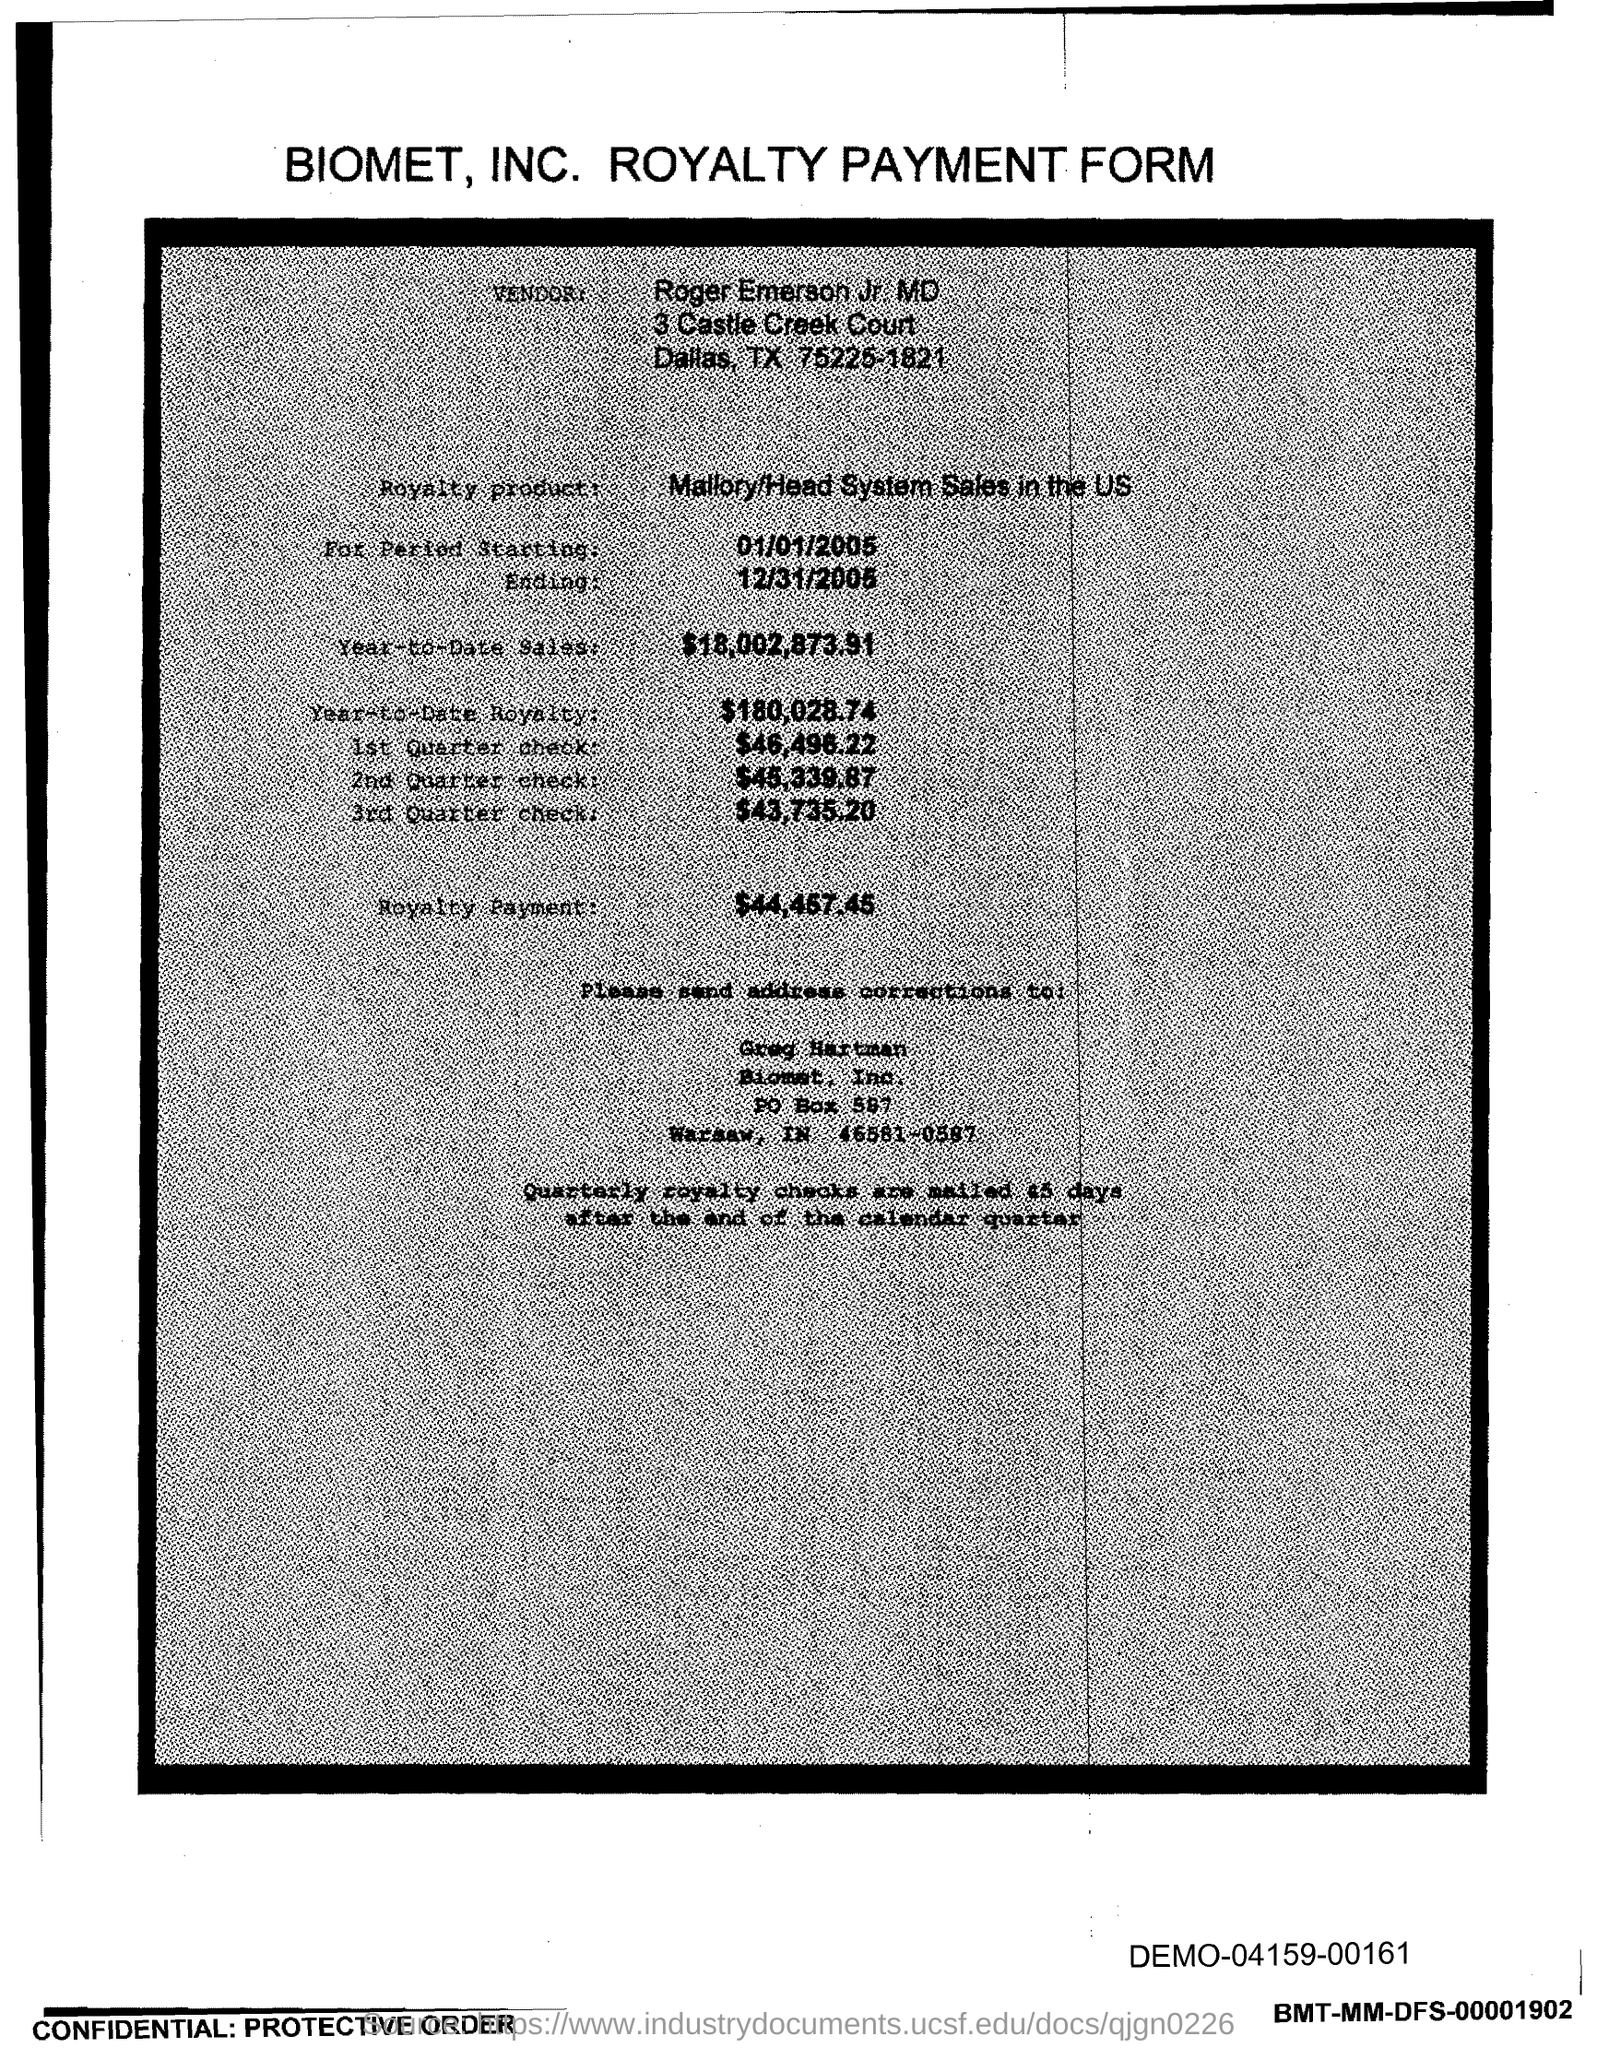Point out several critical features in this image. The royalty period began on January 1, 2005. Year-to-date royalties for the product total $180,028.74. The amount of the third quarter check given in the form is $43,735.20. The end date of the royalty period is December 31, 2005. The year-to-date sales of the royalty product are $18,002,873.91. 